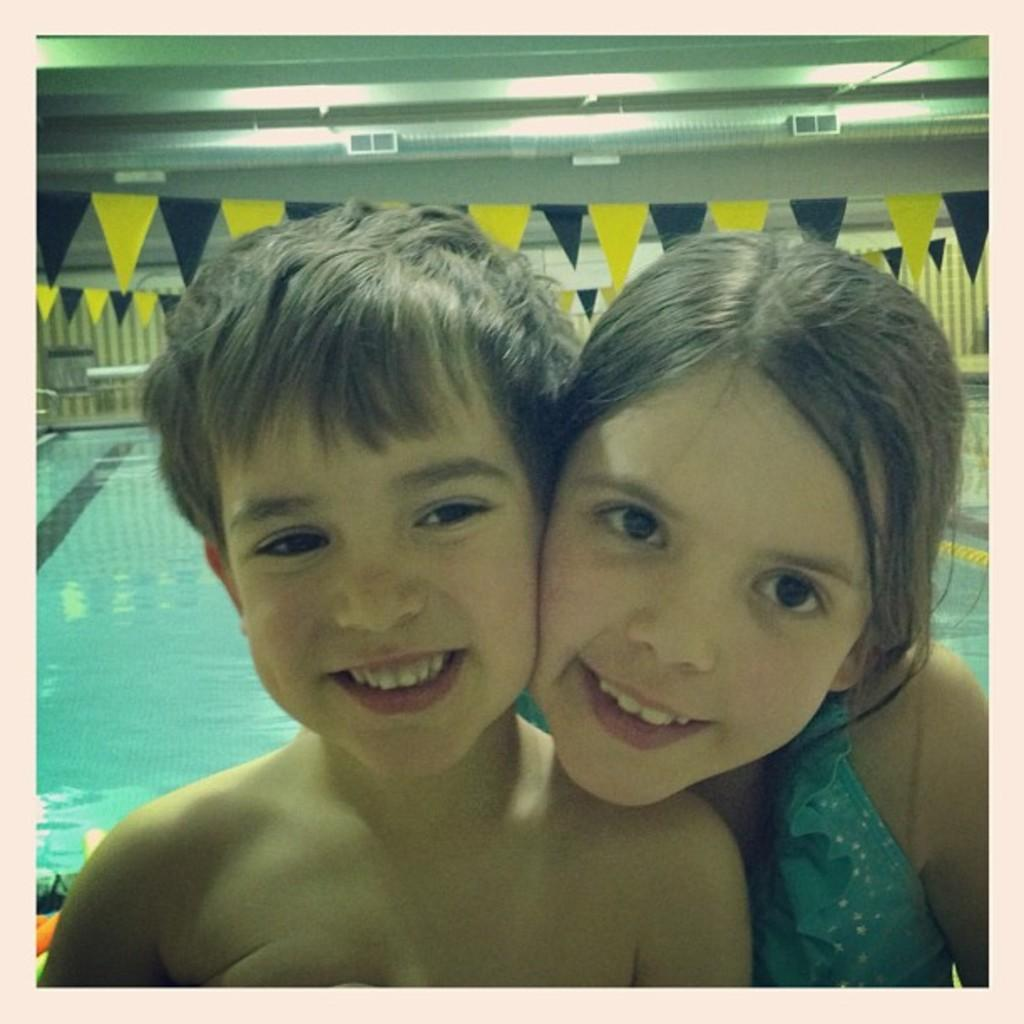How many people are in the image? There are two people in the image, a girl and a boy. What are the expressions on their faces? Both the girl and the boy are smiling in the image. What can be seen in the background of the image? There is a pool, flags, and a wall in the background of the image. How many cobwebs can be seen in the image? There are no cobwebs present in the image. What type of pizzas are being served in the image? There are no pizzas present in the image. 